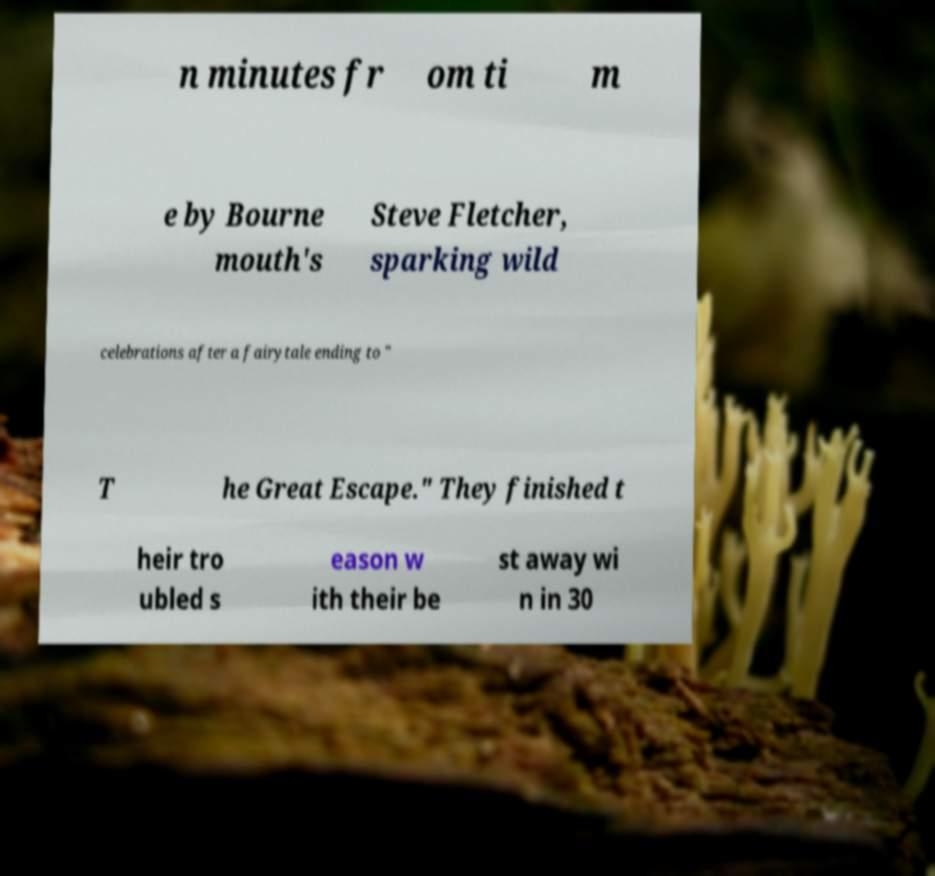There's text embedded in this image that I need extracted. Can you transcribe it verbatim? n minutes fr om ti m e by Bourne mouth's Steve Fletcher, sparking wild celebrations after a fairytale ending to " T he Great Escape." They finished t heir tro ubled s eason w ith their be st away wi n in 30 